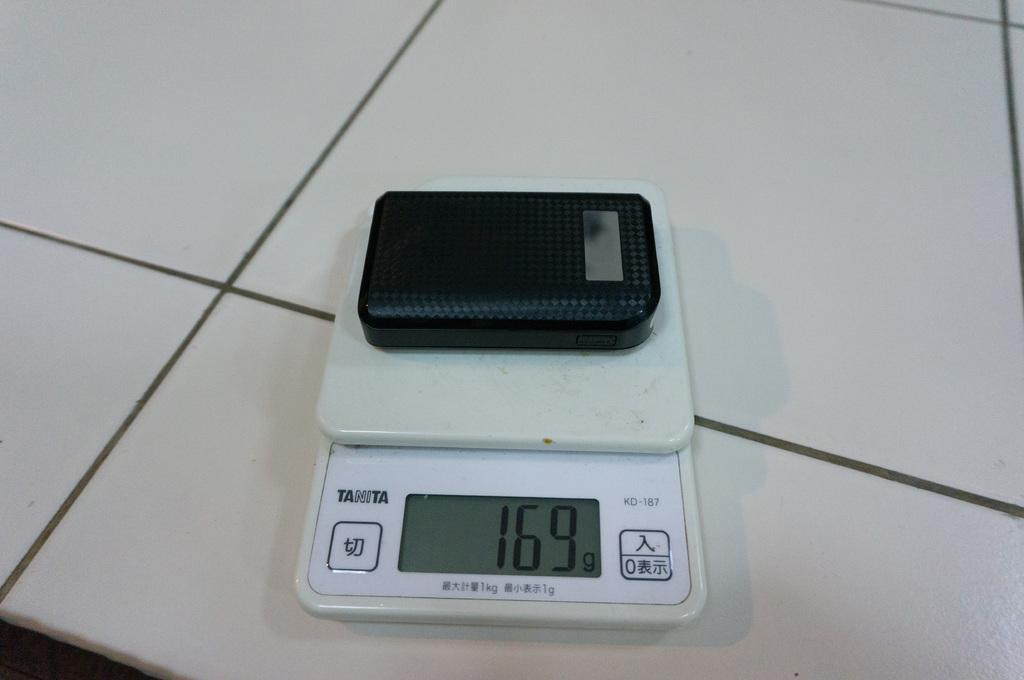<image>
Share a concise interpretation of the image provided. A scale has a black object on it, which weighs 169 grams. 